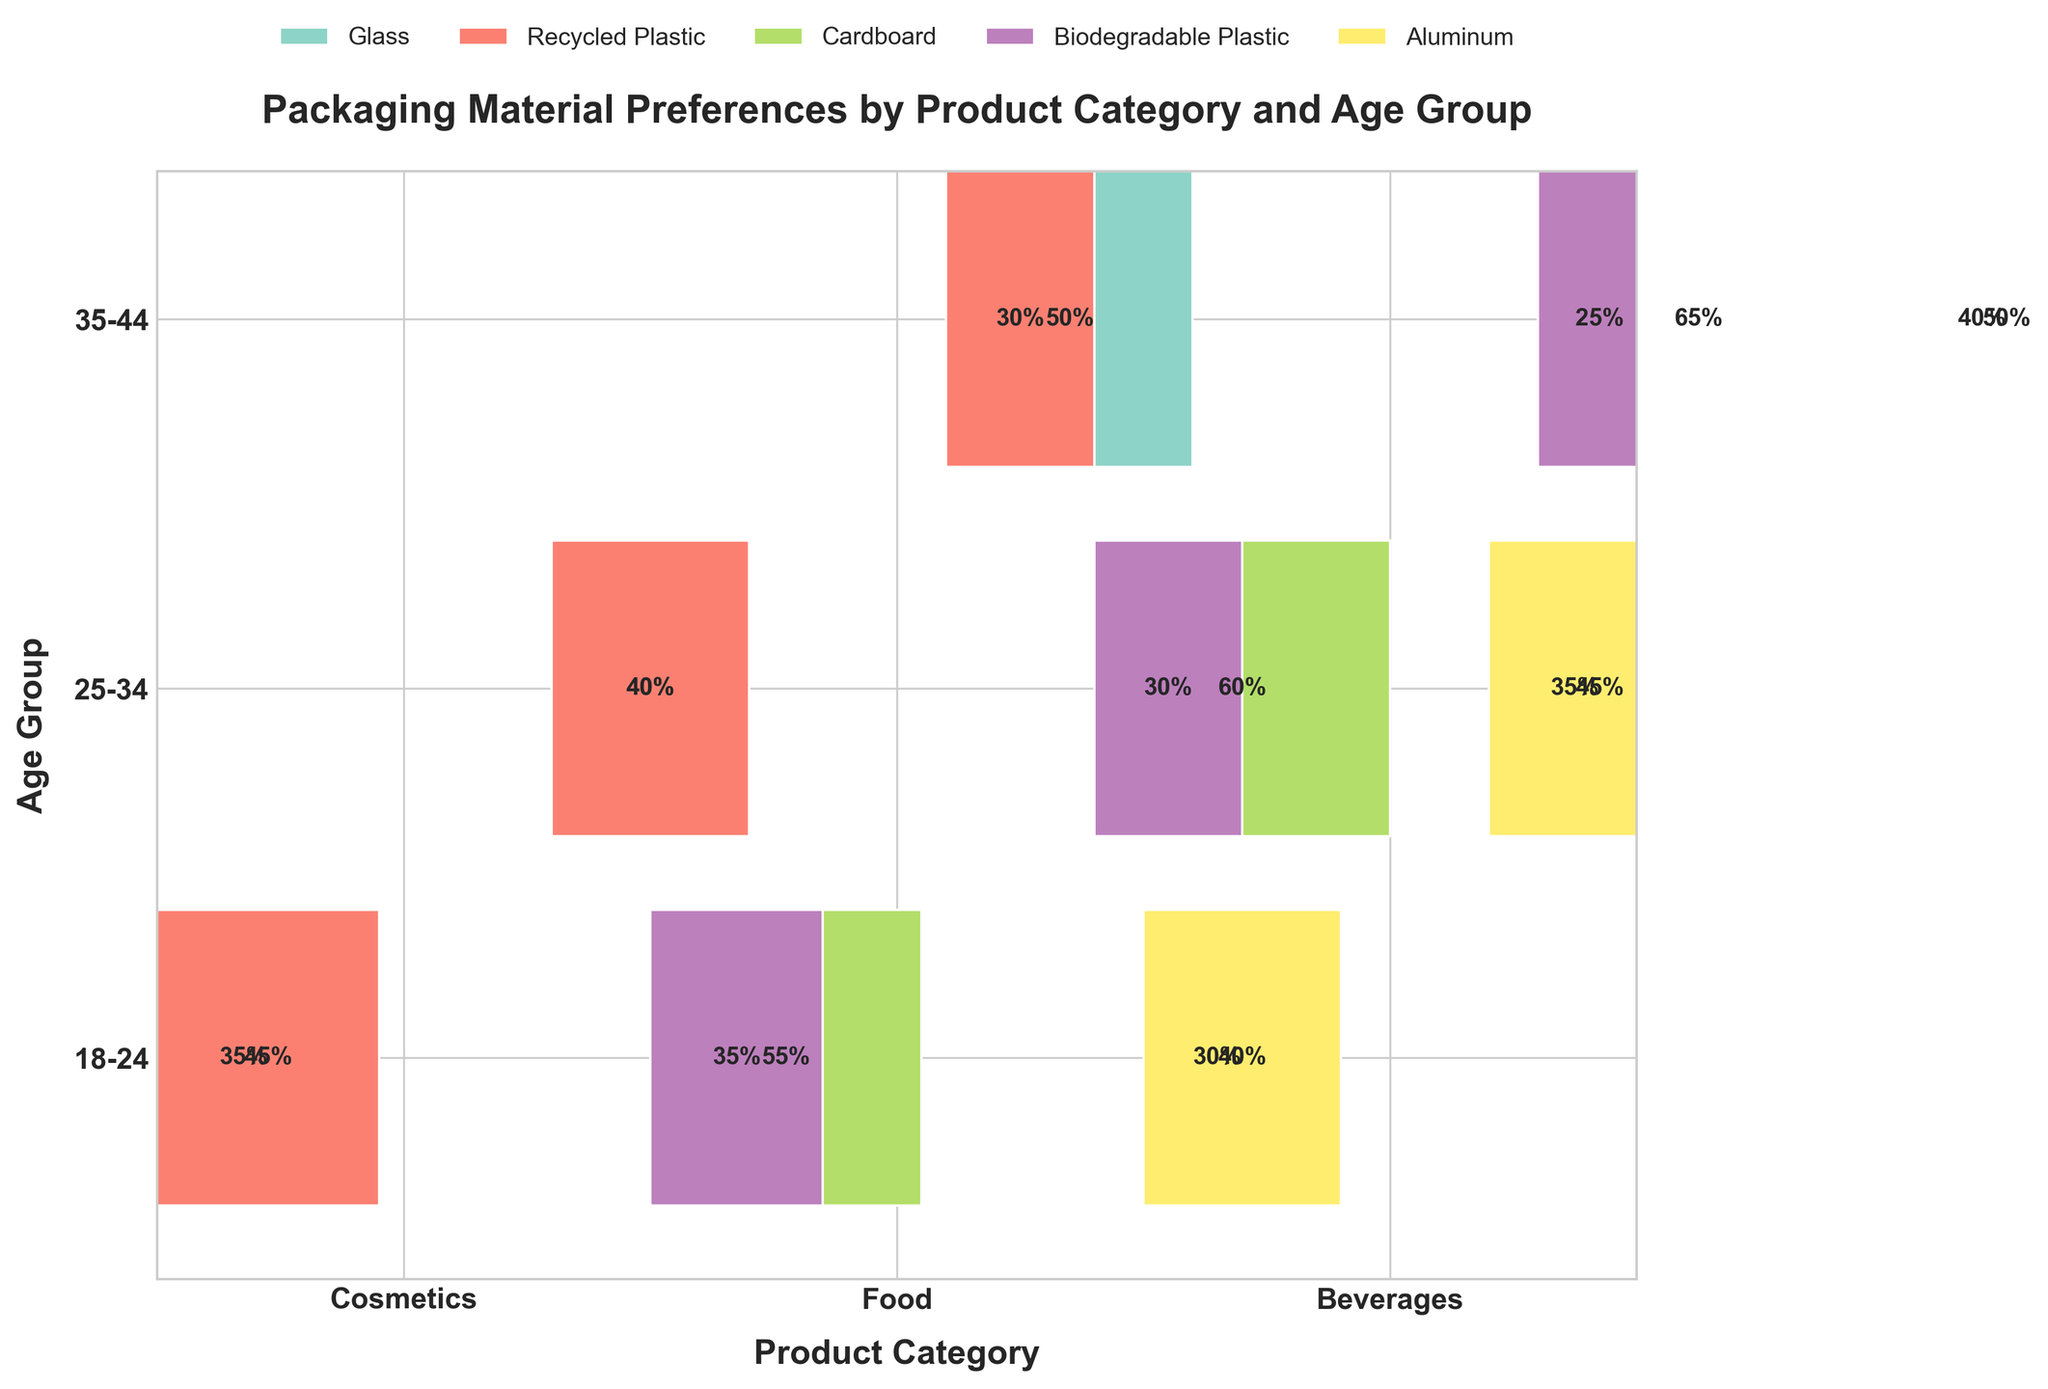What's the title of the mosaic plot? Look at the top of the plot where the title is usually located. The title is written in bold, larger font.
Answer: Packaging Material Preferences by Product Category and Age Group Which age group prefers glass packaging the most for cosmetics? Identify the cosmetics category and compare the percentages for glass packaging across the age groups. The group with the highest percentage indicates the highest preference.
Answer: 35-44 What are the percentages of preferred packaging materials for food in the 25-34 age group? Locate the section for the Food product category and then find the 25-34 age group row. Check the rectangles' width for each material and their corresponding percentage labels.
Answer: Cardboard: 60%, Biodegradable Plastic: 30% How do packaging preferences for beverages change with age from 18-24 to 35-44? Compare the percentages of each packaging material for beverages between the age groups 18-24 and 35-44. Look at the difference in size and percentage labels on the rectangles.
Answer: Aluminum increases from 40% to 50%, Glass increases from 30% to 40% Which product category has the highest preference for recycled plastic, specifically for the 18-24 age group? Look at the 18-24 age group row and find the recycled plastic sections across product categories. Compare the percentage labels or the size of the rectangles.
Answer: Cosmetics For the 25-34 age group, which product category shows a balanced distribution of packaging material preferences? Identify which product category in the 25-34 age group has rectangles of similar sizes or equal percentages for the different packaging materials.
Answer: Cosmetics (Glass: 40%, Recycled Plastic: 40%) What is the least preferred packaging material for beverages in the 25-34 age group? Find the beverages section for the 25-34 age group and identify the packaging material with the smallest rectangle or lowest percentage.
Answer: Glass (35%) Compare the overall preference trend for cardboard packaging material in the food category across the age groups. Identify and compare the cardboard percentages in the food category for each age group. Observe if the percentages increase, decrease, or remain constant across the groups.
Answer: Increasing trend (55% for 18-24, 60% for 25-34, 65% for 35-44) What percentage of beverages is preferred in aluminum packaging by the 25-34 age group? Locate the beverages category and the 25-34 age group row. Find the rectangle for aluminum and read the percentage label.
Answer: 45% 